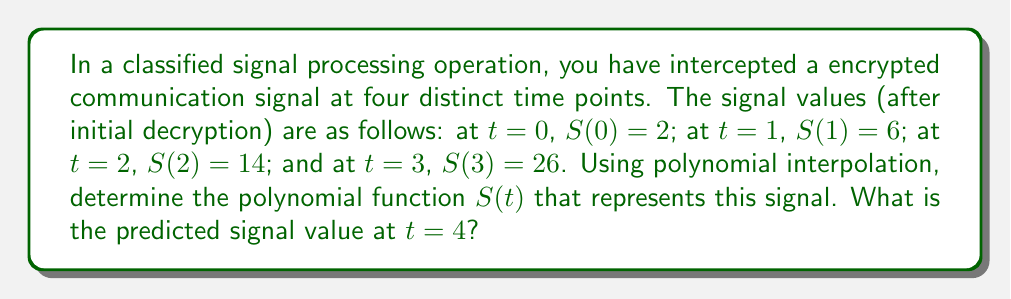Provide a solution to this math problem. To solve this problem, we'll use Lagrange polynomial interpolation:

1) The Lagrange interpolation polynomial is given by:
   $$S(t) = \sum_{i=0}^{n} y_i L_i(t)$$
   where $L_i(t)$ are Lagrange basis polynomials.

2) For our case, $n=3$, and the Lagrange basis polynomials are:
   $$L_0(t) = \frac{(t-1)(t-2)(t-3)}{(0-1)(0-2)(0-3)}$$
   $$L_1(t) = \frac{(t-0)(t-2)(t-3)}{(1-0)(1-2)(1-3)}$$
   $$L_2(t) = \frac{(t-0)(t-1)(t-3)}{(2-0)(2-1)(2-3)}$$
   $$L_3(t) = \frac{(t-0)(t-1)(t-2)}{(3-0)(3-1)(3-2)}$$

3) Simplifying:
   $$L_0(t) = -\frac{1}{6}(t-1)(t-2)(t-3)$$
   $$L_1(t) = \frac{1}{2}t(t-2)(t-3)$$
   $$L_2(t) = -\frac{1}{2}t(t-1)(t-3)$$
   $$L_3(t) = \frac{1}{6}t(t-1)(t-2)$$

4) Now, we can construct $S(t)$:
   $$S(t) = 2L_0(t) + 6L_1(t) + 14L_2(t) + 26L_3(t)$$

5) Expanding and simplifying:
   $$S(t) = -\frac{1}{3}t^3 + 2t^2 + \frac{10}{3}t + 2$$

6) To find the signal value at $t=4$, we substitute $t=4$ into our polynomial:
   $$S(4) = -\frac{1}{3}(4^3) + 2(4^2) + \frac{10}{3}(4) + 2 = 42$$
Answer: $S(t) = -\frac{1}{3}t^3 + 2t^2 + \frac{10}{3}t + 2$; $S(4) = 42$ 